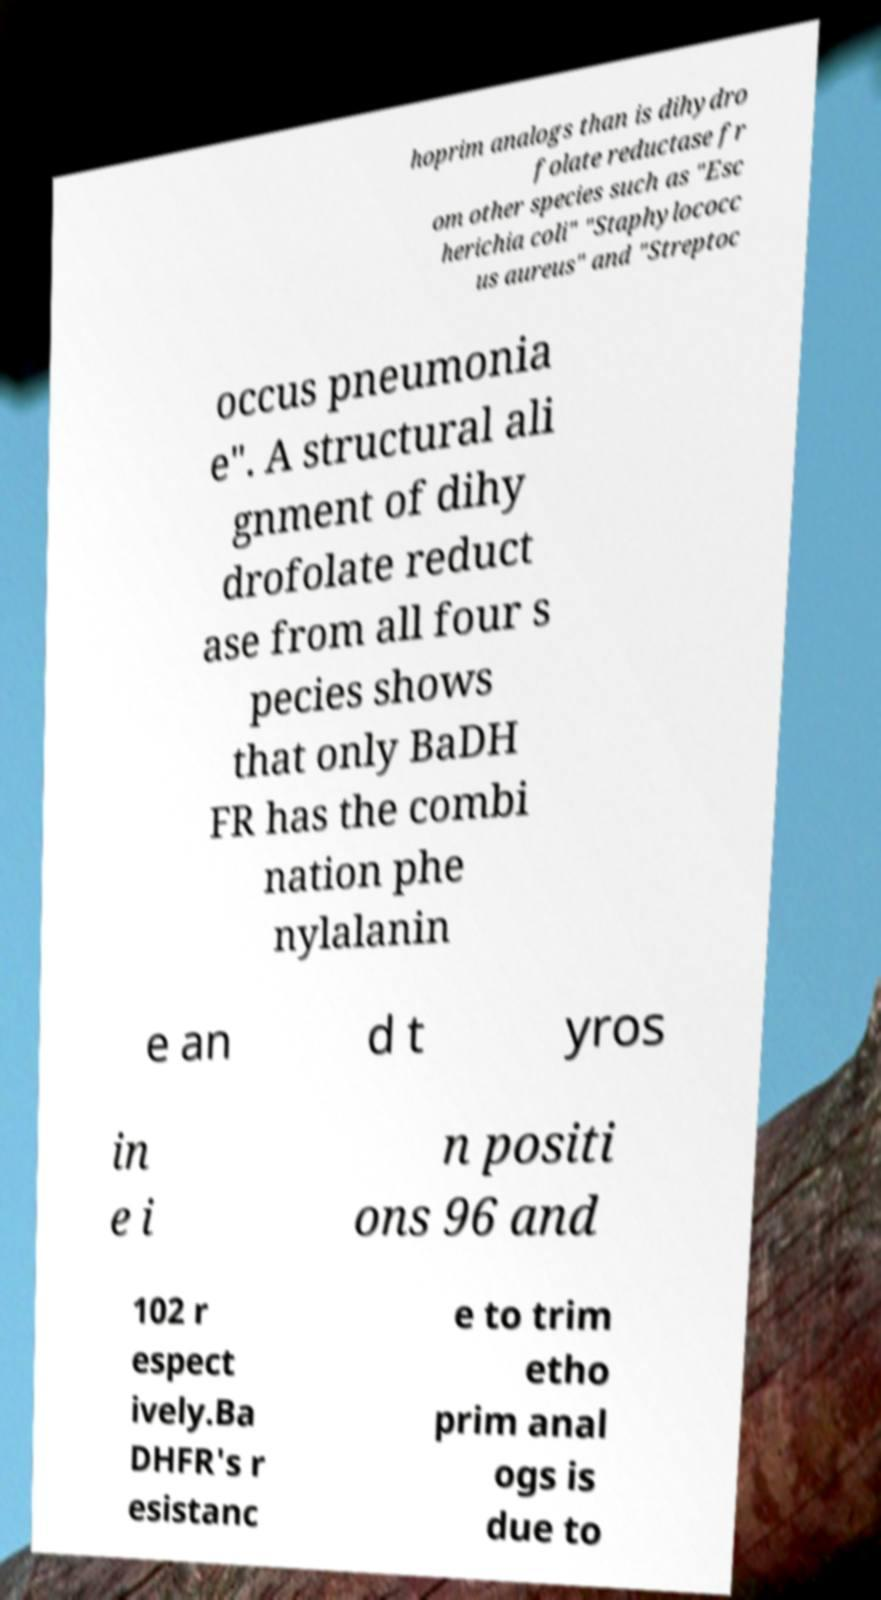I need the written content from this picture converted into text. Can you do that? hoprim analogs than is dihydro folate reductase fr om other species such as "Esc herichia coli" "Staphylococc us aureus" and "Streptoc occus pneumonia e". A structural ali gnment of dihy drofolate reduct ase from all four s pecies shows that only BaDH FR has the combi nation phe nylalanin e an d t yros in e i n positi ons 96 and 102 r espect ively.Ba DHFR's r esistanc e to trim etho prim anal ogs is due to 